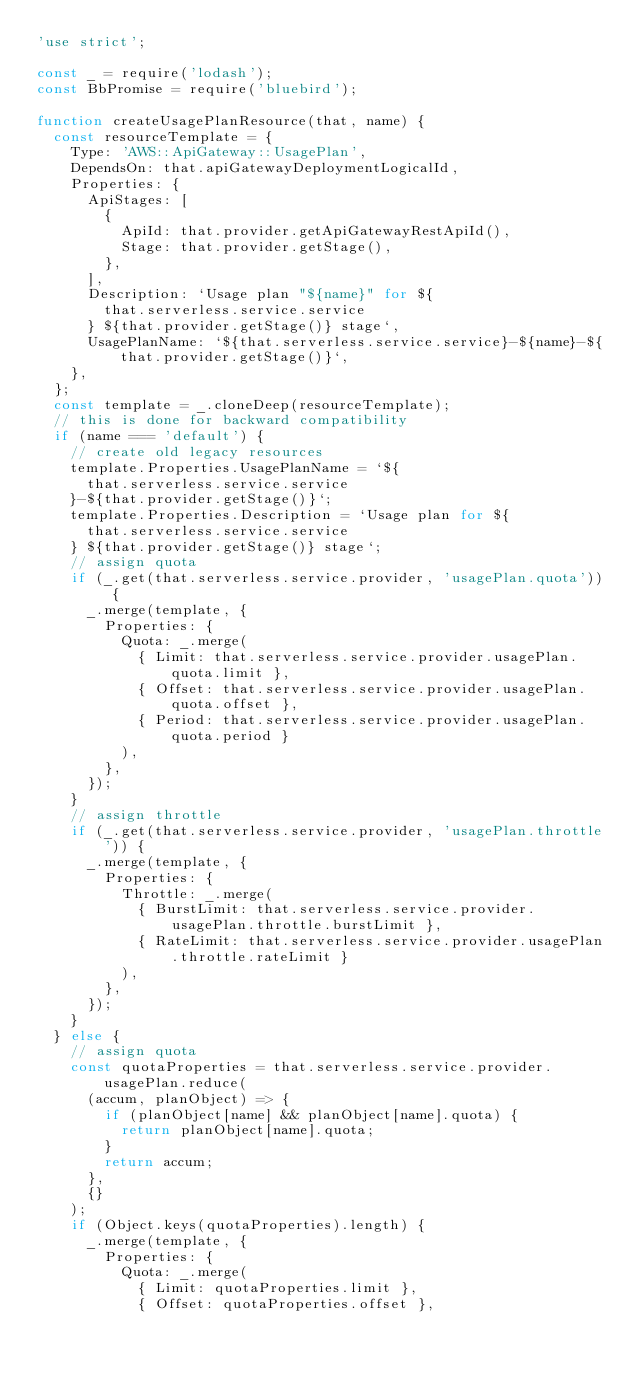Convert code to text. <code><loc_0><loc_0><loc_500><loc_500><_JavaScript_>'use strict';

const _ = require('lodash');
const BbPromise = require('bluebird');

function createUsagePlanResource(that, name) {
  const resourceTemplate = {
    Type: 'AWS::ApiGateway::UsagePlan',
    DependsOn: that.apiGatewayDeploymentLogicalId,
    Properties: {
      ApiStages: [
        {
          ApiId: that.provider.getApiGatewayRestApiId(),
          Stage: that.provider.getStage(),
        },
      ],
      Description: `Usage plan "${name}" for ${
        that.serverless.service.service
      } ${that.provider.getStage()} stage`,
      UsagePlanName: `${that.serverless.service.service}-${name}-${that.provider.getStage()}`,
    },
  };
  const template = _.cloneDeep(resourceTemplate);
  // this is done for backward compatibility
  if (name === 'default') {
    // create old legacy resources
    template.Properties.UsagePlanName = `${
      that.serverless.service.service
    }-${that.provider.getStage()}`;
    template.Properties.Description = `Usage plan for ${
      that.serverless.service.service
    } ${that.provider.getStage()} stage`;
    // assign quota
    if (_.get(that.serverless.service.provider, 'usagePlan.quota')) {
      _.merge(template, {
        Properties: {
          Quota: _.merge(
            { Limit: that.serverless.service.provider.usagePlan.quota.limit },
            { Offset: that.serverless.service.provider.usagePlan.quota.offset },
            { Period: that.serverless.service.provider.usagePlan.quota.period }
          ),
        },
      });
    }
    // assign throttle
    if (_.get(that.serverless.service.provider, 'usagePlan.throttle')) {
      _.merge(template, {
        Properties: {
          Throttle: _.merge(
            { BurstLimit: that.serverless.service.provider.usagePlan.throttle.burstLimit },
            { RateLimit: that.serverless.service.provider.usagePlan.throttle.rateLimit }
          ),
        },
      });
    }
  } else {
    // assign quota
    const quotaProperties = that.serverless.service.provider.usagePlan.reduce(
      (accum, planObject) => {
        if (planObject[name] && planObject[name].quota) {
          return planObject[name].quota;
        }
        return accum;
      },
      {}
    );
    if (Object.keys(quotaProperties).length) {
      _.merge(template, {
        Properties: {
          Quota: _.merge(
            { Limit: quotaProperties.limit },
            { Offset: quotaProperties.offset },</code> 